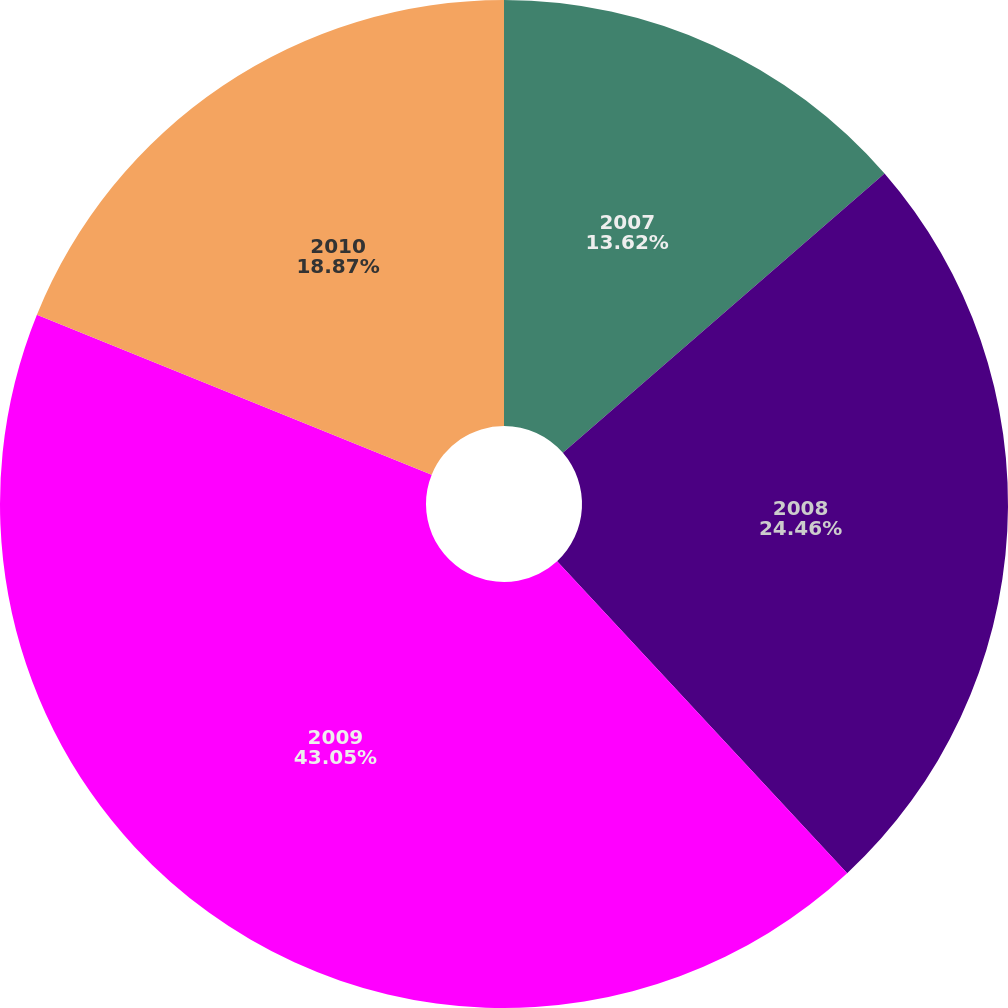Convert chart. <chart><loc_0><loc_0><loc_500><loc_500><pie_chart><fcel>2007<fcel>2008<fcel>2009<fcel>2010<nl><fcel>13.62%<fcel>24.46%<fcel>43.05%<fcel>18.87%<nl></chart> 